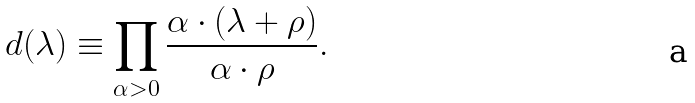<formula> <loc_0><loc_0><loc_500><loc_500>d ( \lambda ) \equiv \prod _ { \alpha > 0 } \frac { \alpha \cdot ( \lambda + \rho ) } { \alpha \cdot \rho } .</formula> 